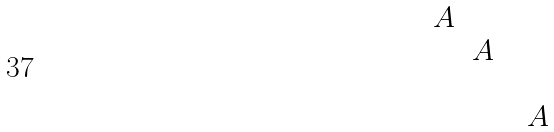<formula> <loc_0><loc_0><loc_500><loc_500>\begin{matrix} A & & & \\ & A & & \\ & & & \\ & & & A \end{matrix}</formula> 